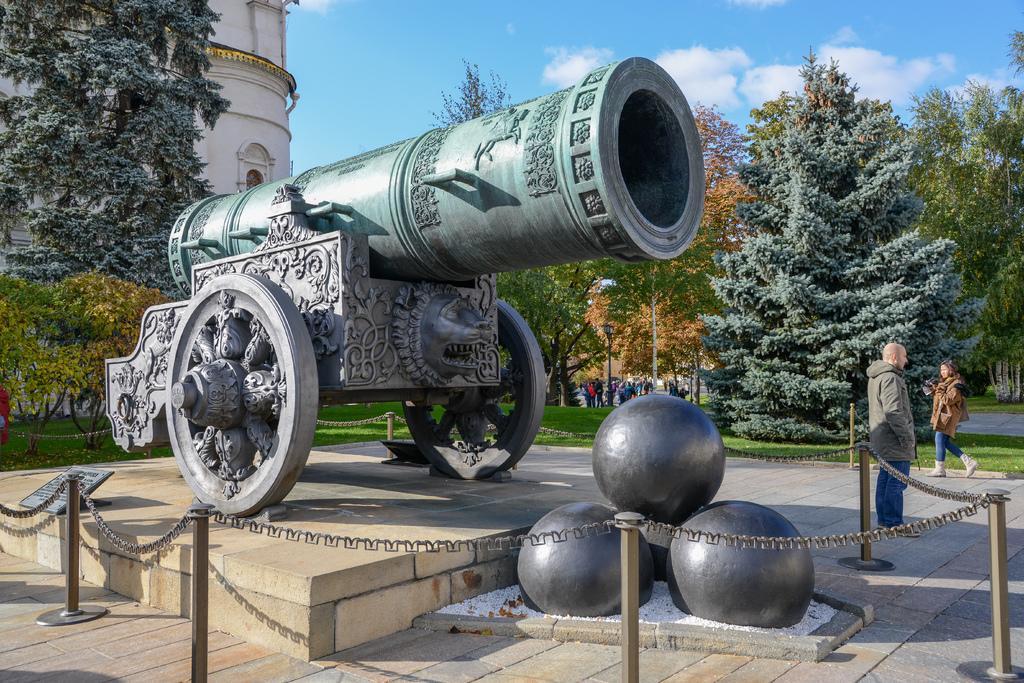Could you give a brief overview of what you see in this image? In the image we can see there is a war equipment kept on the platform, there are three ball structure stones kept on the ground and there is chain fencing around it. There are people standing on the ground and there are trees. There is a building at the back. Behind there are people standing on the ground and the ground is covered with grass. There is a clear sky. 